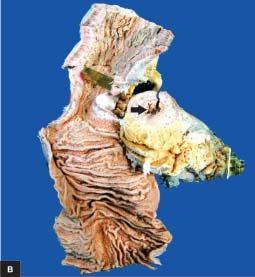does aboratory findings of itp show increased mesenteric fat, thickened wall and narrow lumen?
Answer the question using a single word or phrase. No 